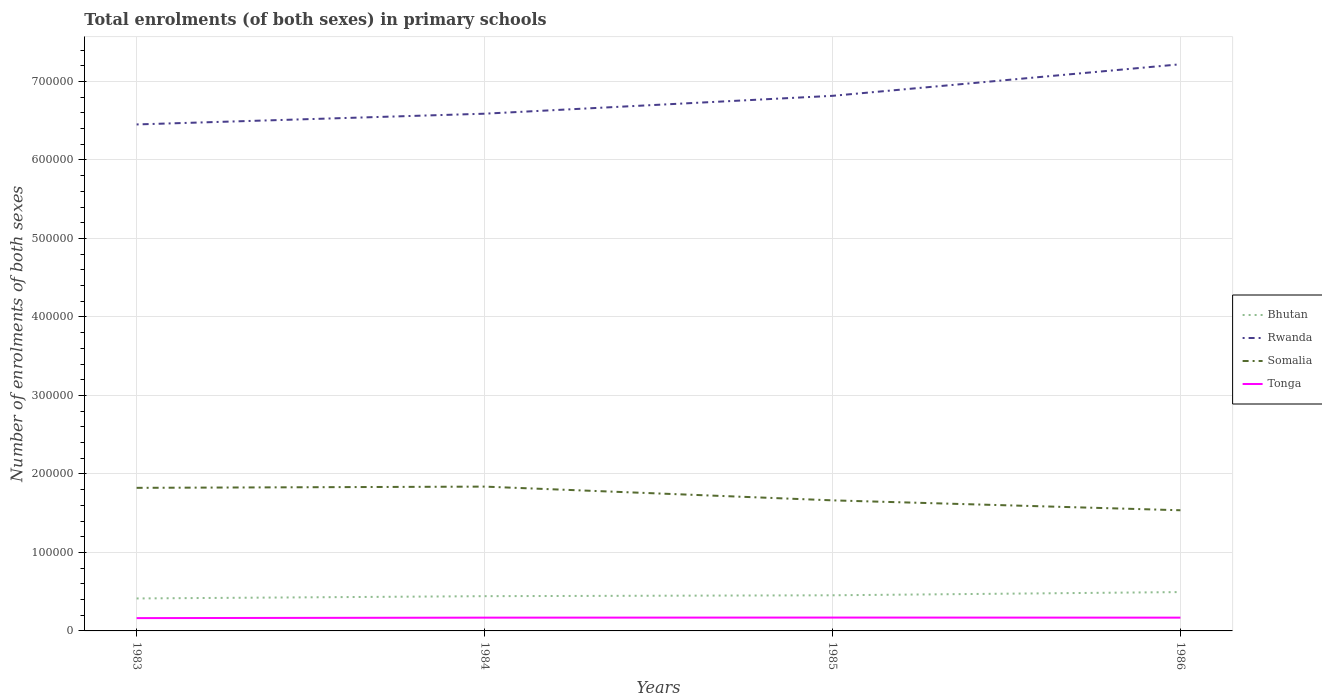Is the number of lines equal to the number of legend labels?
Your answer should be very brief. Yes. Across all years, what is the maximum number of enrolments in primary schools in Tonga?
Give a very brief answer. 1.63e+04. In which year was the number of enrolments in primary schools in Tonga maximum?
Make the answer very short. 1983. What is the total number of enrolments in primary schools in Bhutan in the graph?
Your response must be concise. -8113. What is the difference between the highest and the second highest number of enrolments in primary schools in Rwanda?
Provide a short and direct response. 7.67e+04. How many lines are there?
Offer a terse response. 4. Does the graph contain grids?
Offer a terse response. Yes. How many legend labels are there?
Offer a very short reply. 4. What is the title of the graph?
Make the answer very short. Total enrolments (of both sexes) in primary schools. What is the label or title of the Y-axis?
Provide a short and direct response. Number of enrolments of both sexes. What is the Number of enrolments of both sexes of Bhutan in 1983?
Ensure brevity in your answer.  4.14e+04. What is the Number of enrolments of both sexes of Rwanda in 1983?
Ensure brevity in your answer.  6.45e+05. What is the Number of enrolments of both sexes in Somalia in 1983?
Offer a very short reply. 1.82e+05. What is the Number of enrolments of both sexes of Tonga in 1983?
Keep it short and to the point. 1.63e+04. What is the Number of enrolments of both sexes of Bhutan in 1984?
Offer a very short reply. 4.43e+04. What is the Number of enrolments of both sexes in Rwanda in 1984?
Provide a short and direct response. 6.59e+05. What is the Number of enrolments of both sexes of Somalia in 1984?
Make the answer very short. 1.84e+05. What is the Number of enrolments of both sexes in Tonga in 1984?
Your answer should be compact. 1.69e+04. What is the Number of enrolments of both sexes in Bhutan in 1985?
Keep it short and to the point. 4.54e+04. What is the Number of enrolments of both sexes in Rwanda in 1985?
Provide a short and direct response. 6.82e+05. What is the Number of enrolments of both sexes in Somalia in 1985?
Ensure brevity in your answer.  1.66e+05. What is the Number of enrolments of both sexes in Tonga in 1985?
Your answer should be compact. 1.70e+04. What is the Number of enrolments of both sexes of Bhutan in 1986?
Ensure brevity in your answer.  4.95e+04. What is the Number of enrolments of both sexes in Rwanda in 1986?
Keep it short and to the point. 7.22e+05. What is the Number of enrolments of both sexes of Somalia in 1986?
Provide a short and direct response. 1.54e+05. What is the Number of enrolments of both sexes in Tonga in 1986?
Offer a very short reply. 1.69e+04. Across all years, what is the maximum Number of enrolments of both sexes in Bhutan?
Provide a succinct answer. 4.95e+04. Across all years, what is the maximum Number of enrolments of both sexes in Rwanda?
Offer a terse response. 7.22e+05. Across all years, what is the maximum Number of enrolments of both sexes in Somalia?
Offer a terse response. 1.84e+05. Across all years, what is the maximum Number of enrolments of both sexes in Tonga?
Give a very brief answer. 1.70e+04. Across all years, what is the minimum Number of enrolments of both sexes of Bhutan?
Your response must be concise. 4.14e+04. Across all years, what is the minimum Number of enrolments of both sexes of Rwanda?
Your answer should be very brief. 6.45e+05. Across all years, what is the minimum Number of enrolments of both sexes of Somalia?
Your answer should be compact. 1.54e+05. Across all years, what is the minimum Number of enrolments of both sexes in Tonga?
Make the answer very short. 1.63e+04. What is the total Number of enrolments of both sexes in Bhutan in the graph?
Keep it short and to the point. 1.81e+05. What is the total Number of enrolments of both sexes of Rwanda in the graph?
Your answer should be very brief. 2.71e+06. What is the total Number of enrolments of both sexes in Somalia in the graph?
Your answer should be very brief. 6.86e+05. What is the total Number of enrolments of both sexes in Tonga in the graph?
Provide a succinct answer. 6.72e+04. What is the difference between the Number of enrolments of both sexes in Bhutan in 1983 and that in 1984?
Your answer should be compact. -2903. What is the difference between the Number of enrolments of both sexes in Rwanda in 1983 and that in 1984?
Offer a terse response. -1.37e+04. What is the difference between the Number of enrolments of both sexes of Somalia in 1983 and that in 1984?
Provide a succinct answer. -1564. What is the difference between the Number of enrolments of both sexes of Tonga in 1983 and that in 1984?
Provide a short and direct response. -592. What is the difference between the Number of enrolments of both sexes in Bhutan in 1983 and that in 1985?
Your response must be concise. -4023. What is the difference between the Number of enrolments of both sexes in Rwanda in 1983 and that in 1985?
Provide a short and direct response. -3.65e+04. What is the difference between the Number of enrolments of both sexes in Somalia in 1983 and that in 1985?
Provide a succinct answer. 1.59e+04. What is the difference between the Number of enrolments of both sexes in Tonga in 1983 and that in 1985?
Keep it short and to the point. -690. What is the difference between the Number of enrolments of both sexes of Bhutan in 1983 and that in 1986?
Your answer should be compact. -8113. What is the difference between the Number of enrolments of both sexes in Rwanda in 1983 and that in 1986?
Your answer should be compact. -7.67e+04. What is the difference between the Number of enrolments of both sexes in Somalia in 1983 and that in 1986?
Provide a succinct answer. 2.86e+04. What is the difference between the Number of enrolments of both sexes of Tonga in 1983 and that in 1986?
Your response must be concise. -583. What is the difference between the Number of enrolments of both sexes in Bhutan in 1984 and that in 1985?
Offer a terse response. -1120. What is the difference between the Number of enrolments of both sexes of Rwanda in 1984 and that in 1985?
Your answer should be very brief. -2.28e+04. What is the difference between the Number of enrolments of both sexes of Somalia in 1984 and that in 1985?
Keep it short and to the point. 1.75e+04. What is the difference between the Number of enrolments of both sexes of Tonga in 1984 and that in 1985?
Give a very brief answer. -98. What is the difference between the Number of enrolments of both sexes of Bhutan in 1984 and that in 1986?
Make the answer very short. -5210. What is the difference between the Number of enrolments of both sexes in Rwanda in 1984 and that in 1986?
Offer a very short reply. -6.30e+04. What is the difference between the Number of enrolments of both sexes of Somalia in 1984 and that in 1986?
Give a very brief answer. 3.01e+04. What is the difference between the Number of enrolments of both sexes in Bhutan in 1985 and that in 1986?
Your response must be concise. -4090. What is the difference between the Number of enrolments of both sexes of Rwanda in 1985 and that in 1986?
Provide a short and direct response. -4.02e+04. What is the difference between the Number of enrolments of both sexes in Somalia in 1985 and that in 1986?
Your response must be concise. 1.26e+04. What is the difference between the Number of enrolments of both sexes in Tonga in 1985 and that in 1986?
Provide a short and direct response. 107. What is the difference between the Number of enrolments of both sexes of Bhutan in 1983 and the Number of enrolments of both sexes of Rwanda in 1984?
Offer a very short reply. -6.18e+05. What is the difference between the Number of enrolments of both sexes of Bhutan in 1983 and the Number of enrolments of both sexes of Somalia in 1984?
Your answer should be very brief. -1.42e+05. What is the difference between the Number of enrolments of both sexes in Bhutan in 1983 and the Number of enrolments of both sexes in Tonga in 1984?
Provide a succinct answer. 2.45e+04. What is the difference between the Number of enrolments of both sexes of Rwanda in 1983 and the Number of enrolments of both sexes of Somalia in 1984?
Ensure brevity in your answer.  4.61e+05. What is the difference between the Number of enrolments of both sexes in Rwanda in 1983 and the Number of enrolments of both sexes in Tonga in 1984?
Your answer should be very brief. 6.28e+05. What is the difference between the Number of enrolments of both sexes in Somalia in 1983 and the Number of enrolments of both sexes in Tonga in 1984?
Offer a terse response. 1.65e+05. What is the difference between the Number of enrolments of both sexes in Bhutan in 1983 and the Number of enrolments of both sexes in Rwanda in 1985?
Offer a terse response. -6.40e+05. What is the difference between the Number of enrolments of both sexes in Bhutan in 1983 and the Number of enrolments of both sexes in Somalia in 1985?
Offer a terse response. -1.25e+05. What is the difference between the Number of enrolments of both sexes in Bhutan in 1983 and the Number of enrolments of both sexes in Tonga in 1985?
Your answer should be very brief. 2.44e+04. What is the difference between the Number of enrolments of both sexes of Rwanda in 1983 and the Number of enrolments of both sexes of Somalia in 1985?
Give a very brief answer. 4.79e+05. What is the difference between the Number of enrolments of both sexes in Rwanda in 1983 and the Number of enrolments of both sexes in Tonga in 1985?
Offer a terse response. 6.28e+05. What is the difference between the Number of enrolments of both sexes in Somalia in 1983 and the Number of enrolments of both sexes in Tonga in 1985?
Offer a terse response. 1.65e+05. What is the difference between the Number of enrolments of both sexes in Bhutan in 1983 and the Number of enrolments of both sexes in Rwanda in 1986?
Your response must be concise. -6.80e+05. What is the difference between the Number of enrolments of both sexes of Bhutan in 1983 and the Number of enrolments of both sexes of Somalia in 1986?
Keep it short and to the point. -1.12e+05. What is the difference between the Number of enrolments of both sexes of Bhutan in 1983 and the Number of enrolments of both sexes of Tonga in 1986?
Provide a short and direct response. 2.45e+04. What is the difference between the Number of enrolments of both sexes of Rwanda in 1983 and the Number of enrolments of both sexes of Somalia in 1986?
Make the answer very short. 4.91e+05. What is the difference between the Number of enrolments of both sexes in Rwanda in 1983 and the Number of enrolments of both sexes in Tonga in 1986?
Provide a short and direct response. 6.28e+05. What is the difference between the Number of enrolments of both sexes of Somalia in 1983 and the Number of enrolments of both sexes of Tonga in 1986?
Ensure brevity in your answer.  1.65e+05. What is the difference between the Number of enrolments of both sexes of Bhutan in 1984 and the Number of enrolments of both sexes of Rwanda in 1985?
Make the answer very short. -6.37e+05. What is the difference between the Number of enrolments of both sexes of Bhutan in 1984 and the Number of enrolments of both sexes of Somalia in 1985?
Your response must be concise. -1.22e+05. What is the difference between the Number of enrolments of both sexes in Bhutan in 1984 and the Number of enrolments of both sexes in Tonga in 1985?
Make the answer very short. 2.73e+04. What is the difference between the Number of enrolments of both sexes of Rwanda in 1984 and the Number of enrolments of both sexes of Somalia in 1985?
Give a very brief answer. 4.93e+05. What is the difference between the Number of enrolments of both sexes in Rwanda in 1984 and the Number of enrolments of both sexes in Tonga in 1985?
Offer a terse response. 6.42e+05. What is the difference between the Number of enrolments of both sexes in Somalia in 1984 and the Number of enrolments of both sexes in Tonga in 1985?
Keep it short and to the point. 1.67e+05. What is the difference between the Number of enrolments of both sexes in Bhutan in 1984 and the Number of enrolments of both sexes in Rwanda in 1986?
Keep it short and to the point. -6.78e+05. What is the difference between the Number of enrolments of both sexes in Bhutan in 1984 and the Number of enrolments of both sexes in Somalia in 1986?
Give a very brief answer. -1.09e+05. What is the difference between the Number of enrolments of both sexes of Bhutan in 1984 and the Number of enrolments of both sexes of Tonga in 1986?
Give a very brief answer. 2.74e+04. What is the difference between the Number of enrolments of both sexes in Rwanda in 1984 and the Number of enrolments of both sexes in Somalia in 1986?
Offer a very short reply. 5.05e+05. What is the difference between the Number of enrolments of both sexes in Rwanda in 1984 and the Number of enrolments of both sexes in Tonga in 1986?
Offer a very short reply. 6.42e+05. What is the difference between the Number of enrolments of both sexes of Somalia in 1984 and the Number of enrolments of both sexes of Tonga in 1986?
Offer a terse response. 1.67e+05. What is the difference between the Number of enrolments of both sexes of Bhutan in 1985 and the Number of enrolments of both sexes of Rwanda in 1986?
Keep it short and to the point. -6.76e+05. What is the difference between the Number of enrolments of both sexes of Bhutan in 1985 and the Number of enrolments of both sexes of Somalia in 1986?
Give a very brief answer. -1.08e+05. What is the difference between the Number of enrolments of both sexes of Bhutan in 1985 and the Number of enrolments of both sexes of Tonga in 1986?
Make the answer very short. 2.85e+04. What is the difference between the Number of enrolments of both sexes of Rwanda in 1985 and the Number of enrolments of both sexes of Somalia in 1986?
Offer a terse response. 5.28e+05. What is the difference between the Number of enrolments of both sexes of Rwanda in 1985 and the Number of enrolments of both sexes of Tonga in 1986?
Give a very brief answer. 6.65e+05. What is the difference between the Number of enrolments of both sexes of Somalia in 1985 and the Number of enrolments of both sexes of Tonga in 1986?
Provide a short and direct response. 1.49e+05. What is the average Number of enrolments of both sexes of Bhutan per year?
Your answer should be compact. 4.51e+04. What is the average Number of enrolments of both sexes of Rwanda per year?
Offer a very short reply. 6.77e+05. What is the average Number of enrolments of both sexes of Somalia per year?
Offer a terse response. 1.72e+05. What is the average Number of enrolments of both sexes in Tonga per year?
Provide a succinct answer. 1.68e+04. In the year 1983, what is the difference between the Number of enrolments of both sexes of Bhutan and Number of enrolments of both sexes of Rwanda?
Offer a terse response. -6.04e+05. In the year 1983, what is the difference between the Number of enrolments of both sexes of Bhutan and Number of enrolments of both sexes of Somalia?
Offer a terse response. -1.41e+05. In the year 1983, what is the difference between the Number of enrolments of both sexes in Bhutan and Number of enrolments of both sexes in Tonga?
Offer a very short reply. 2.50e+04. In the year 1983, what is the difference between the Number of enrolments of both sexes of Rwanda and Number of enrolments of both sexes of Somalia?
Provide a short and direct response. 4.63e+05. In the year 1983, what is the difference between the Number of enrolments of both sexes of Rwanda and Number of enrolments of both sexes of Tonga?
Your answer should be very brief. 6.29e+05. In the year 1983, what is the difference between the Number of enrolments of both sexes in Somalia and Number of enrolments of both sexes in Tonga?
Make the answer very short. 1.66e+05. In the year 1984, what is the difference between the Number of enrolments of both sexes of Bhutan and Number of enrolments of both sexes of Rwanda?
Provide a short and direct response. -6.15e+05. In the year 1984, what is the difference between the Number of enrolments of both sexes in Bhutan and Number of enrolments of both sexes in Somalia?
Your answer should be compact. -1.40e+05. In the year 1984, what is the difference between the Number of enrolments of both sexes in Bhutan and Number of enrolments of both sexes in Tonga?
Your response must be concise. 2.74e+04. In the year 1984, what is the difference between the Number of enrolments of both sexes of Rwanda and Number of enrolments of both sexes of Somalia?
Your answer should be compact. 4.75e+05. In the year 1984, what is the difference between the Number of enrolments of both sexes in Rwanda and Number of enrolments of both sexes in Tonga?
Give a very brief answer. 6.42e+05. In the year 1984, what is the difference between the Number of enrolments of both sexes of Somalia and Number of enrolments of both sexes of Tonga?
Keep it short and to the point. 1.67e+05. In the year 1985, what is the difference between the Number of enrolments of both sexes in Bhutan and Number of enrolments of both sexes in Rwanda?
Give a very brief answer. -6.36e+05. In the year 1985, what is the difference between the Number of enrolments of both sexes of Bhutan and Number of enrolments of both sexes of Somalia?
Make the answer very short. -1.21e+05. In the year 1985, what is the difference between the Number of enrolments of both sexes in Bhutan and Number of enrolments of both sexes in Tonga?
Your response must be concise. 2.84e+04. In the year 1985, what is the difference between the Number of enrolments of both sexes of Rwanda and Number of enrolments of both sexes of Somalia?
Make the answer very short. 5.15e+05. In the year 1985, what is the difference between the Number of enrolments of both sexes in Rwanda and Number of enrolments of both sexes in Tonga?
Your response must be concise. 6.65e+05. In the year 1985, what is the difference between the Number of enrolments of both sexes in Somalia and Number of enrolments of both sexes in Tonga?
Your answer should be very brief. 1.49e+05. In the year 1986, what is the difference between the Number of enrolments of both sexes of Bhutan and Number of enrolments of both sexes of Rwanda?
Keep it short and to the point. -6.72e+05. In the year 1986, what is the difference between the Number of enrolments of both sexes of Bhutan and Number of enrolments of both sexes of Somalia?
Offer a very short reply. -1.04e+05. In the year 1986, what is the difference between the Number of enrolments of both sexes in Bhutan and Number of enrolments of both sexes in Tonga?
Ensure brevity in your answer.  3.26e+04. In the year 1986, what is the difference between the Number of enrolments of both sexes in Rwanda and Number of enrolments of both sexes in Somalia?
Make the answer very short. 5.68e+05. In the year 1986, what is the difference between the Number of enrolments of both sexes in Rwanda and Number of enrolments of both sexes in Tonga?
Your answer should be compact. 7.05e+05. In the year 1986, what is the difference between the Number of enrolments of both sexes of Somalia and Number of enrolments of both sexes of Tonga?
Your response must be concise. 1.37e+05. What is the ratio of the Number of enrolments of both sexes in Bhutan in 1983 to that in 1984?
Keep it short and to the point. 0.93. What is the ratio of the Number of enrolments of both sexes in Rwanda in 1983 to that in 1984?
Provide a short and direct response. 0.98. What is the ratio of the Number of enrolments of both sexes of Somalia in 1983 to that in 1984?
Make the answer very short. 0.99. What is the ratio of the Number of enrolments of both sexes of Bhutan in 1983 to that in 1985?
Provide a succinct answer. 0.91. What is the ratio of the Number of enrolments of both sexes in Rwanda in 1983 to that in 1985?
Offer a very short reply. 0.95. What is the ratio of the Number of enrolments of both sexes in Somalia in 1983 to that in 1985?
Your answer should be very brief. 1.1. What is the ratio of the Number of enrolments of both sexes of Tonga in 1983 to that in 1985?
Your response must be concise. 0.96. What is the ratio of the Number of enrolments of both sexes in Bhutan in 1983 to that in 1986?
Keep it short and to the point. 0.84. What is the ratio of the Number of enrolments of both sexes of Rwanda in 1983 to that in 1986?
Provide a succinct answer. 0.89. What is the ratio of the Number of enrolments of both sexes of Somalia in 1983 to that in 1986?
Your answer should be very brief. 1.19. What is the ratio of the Number of enrolments of both sexes in Tonga in 1983 to that in 1986?
Offer a terse response. 0.97. What is the ratio of the Number of enrolments of both sexes of Bhutan in 1984 to that in 1985?
Your answer should be very brief. 0.98. What is the ratio of the Number of enrolments of both sexes in Rwanda in 1984 to that in 1985?
Keep it short and to the point. 0.97. What is the ratio of the Number of enrolments of both sexes of Somalia in 1984 to that in 1985?
Provide a short and direct response. 1.11. What is the ratio of the Number of enrolments of both sexes in Tonga in 1984 to that in 1985?
Offer a terse response. 0.99. What is the ratio of the Number of enrolments of both sexes of Bhutan in 1984 to that in 1986?
Offer a very short reply. 0.89. What is the ratio of the Number of enrolments of both sexes of Rwanda in 1984 to that in 1986?
Offer a terse response. 0.91. What is the ratio of the Number of enrolments of both sexes of Somalia in 1984 to that in 1986?
Offer a terse response. 1.2. What is the ratio of the Number of enrolments of both sexes in Bhutan in 1985 to that in 1986?
Ensure brevity in your answer.  0.92. What is the ratio of the Number of enrolments of both sexes of Rwanda in 1985 to that in 1986?
Your answer should be compact. 0.94. What is the ratio of the Number of enrolments of both sexes of Somalia in 1985 to that in 1986?
Make the answer very short. 1.08. What is the ratio of the Number of enrolments of both sexes in Tonga in 1985 to that in 1986?
Your answer should be compact. 1.01. What is the difference between the highest and the second highest Number of enrolments of both sexes in Bhutan?
Offer a very short reply. 4090. What is the difference between the highest and the second highest Number of enrolments of both sexes of Rwanda?
Offer a very short reply. 4.02e+04. What is the difference between the highest and the second highest Number of enrolments of both sexes in Somalia?
Offer a terse response. 1564. What is the difference between the highest and the second highest Number of enrolments of both sexes in Tonga?
Make the answer very short. 98. What is the difference between the highest and the lowest Number of enrolments of both sexes of Bhutan?
Provide a short and direct response. 8113. What is the difference between the highest and the lowest Number of enrolments of both sexes in Rwanda?
Your answer should be compact. 7.67e+04. What is the difference between the highest and the lowest Number of enrolments of both sexes of Somalia?
Your answer should be very brief. 3.01e+04. What is the difference between the highest and the lowest Number of enrolments of both sexes of Tonga?
Make the answer very short. 690. 